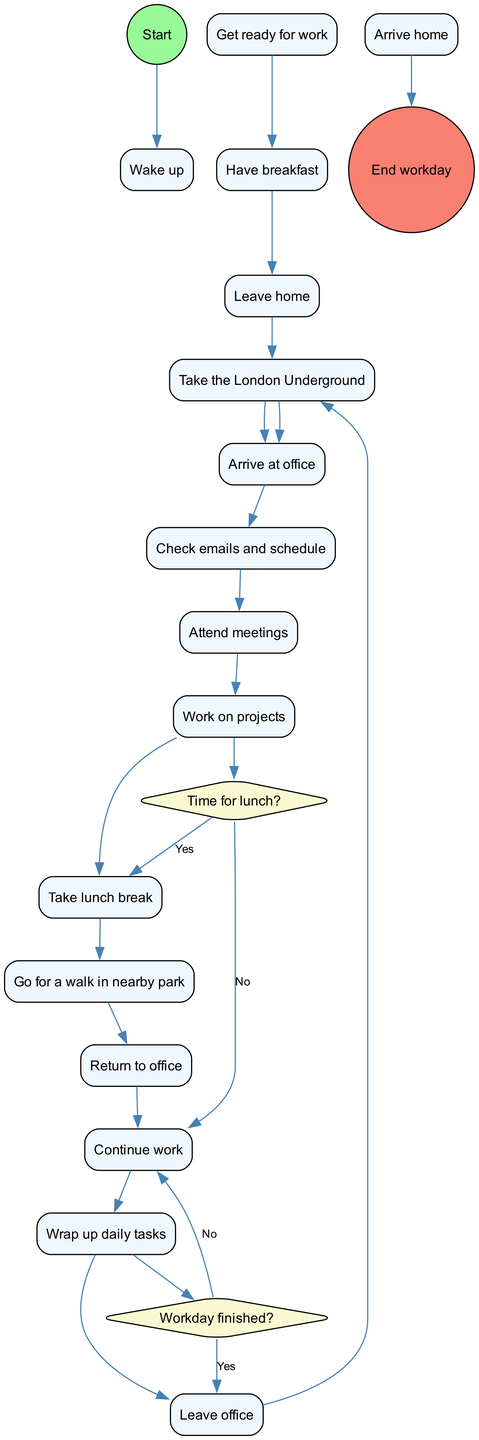What is the first activity after waking up? The diagram indicates that after the "Wake up" node, the next activity listed is "Get ready for work". This is a direct follow-up to the start of the workday sequence.
Answer: Get ready for work How many activities are there in total? The diagram lists a total of 15 distinct activities, including "Wake up" and "End workday", by counting each node in the activities section.
Answer: 15 What is the condition before taking a lunch break? According to the diagram, the decision before taking a lunch break is based on the condition "Time for lunch?". If the answer is yes, the workflow allows for the lunch break; otherwise, it continues working.
Answer: Time for lunch? What comes after “Continue work” when the workday is not finished? The diagram indicates that after the activity "Continue work", it loops back to the "Check emails and schedule" if the workday is not finished. This shows the repetitive nature of work until the day concludes.
Answer: Check emails and schedule Which activity follows after "Have breakfast"? The diagram clearly shows that "Leave home" is the next activity that follows immediately after "Have breakfast", indicating the transition from morning routines to commuting.
Answer: Leave home What decision comes after "Take lunch break"? After the "Take lunch break" activity, the diagram shows the decision "Workday finished?", which determines whether the individual leaves the office or continues to work depending on the answer.
Answer: Workday finished? What is the last activity before the end of the workday? The diagram indicates "Arrive home" as the last activity before reaching the "End workday". This marks the completion of the daily workflow for the professional.
Answer: Arrive home How many decisions are present in the diagram? By examining the diagram, it is evident that there are 2 decisions outlined in the workflow: the one for lunch and the one for the end of the workday.
Answer: 2 Which activity occurs just before “Wrap up daily tasks”? The diagram states that the activity just prior to "Wrap up daily tasks" is "Continue work", following the typical flow of completing assignments before finishing for the day.
Answer: Continue work 